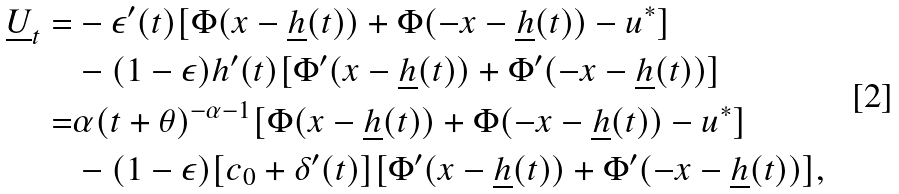Convert formula to latex. <formula><loc_0><loc_0><loc_500><loc_500>\underline { U } _ { t } = & - \epsilon ^ { \prime } ( t ) [ \Phi ( x - \underline { h } ( t ) ) + \Phi ( - x - \underline { h } ( t ) ) - u ^ { * } ] \\ & - ( 1 - \epsilon ) h ^ { \prime } ( t ) [ \Phi ^ { \prime } ( x - \underline { h } ( t ) ) + \Phi ^ { \prime } ( - x - \underline { h } ( t ) ) ] \\ = & \alpha ( t + \theta ) ^ { - \alpha - 1 } [ \Phi ( x - \underline { h } ( t ) ) + \Phi ( - x - \underline { h } ( t ) ) - u ^ { * } ] \\ & - ( 1 - \epsilon ) [ c _ { 0 } + \delta ^ { \prime } ( t ) ] [ \Phi ^ { \prime } ( x - \underline { h } ( t ) ) + \Phi ^ { \prime } ( - x - \underline { h } ( t ) ) ] ,</formula> 